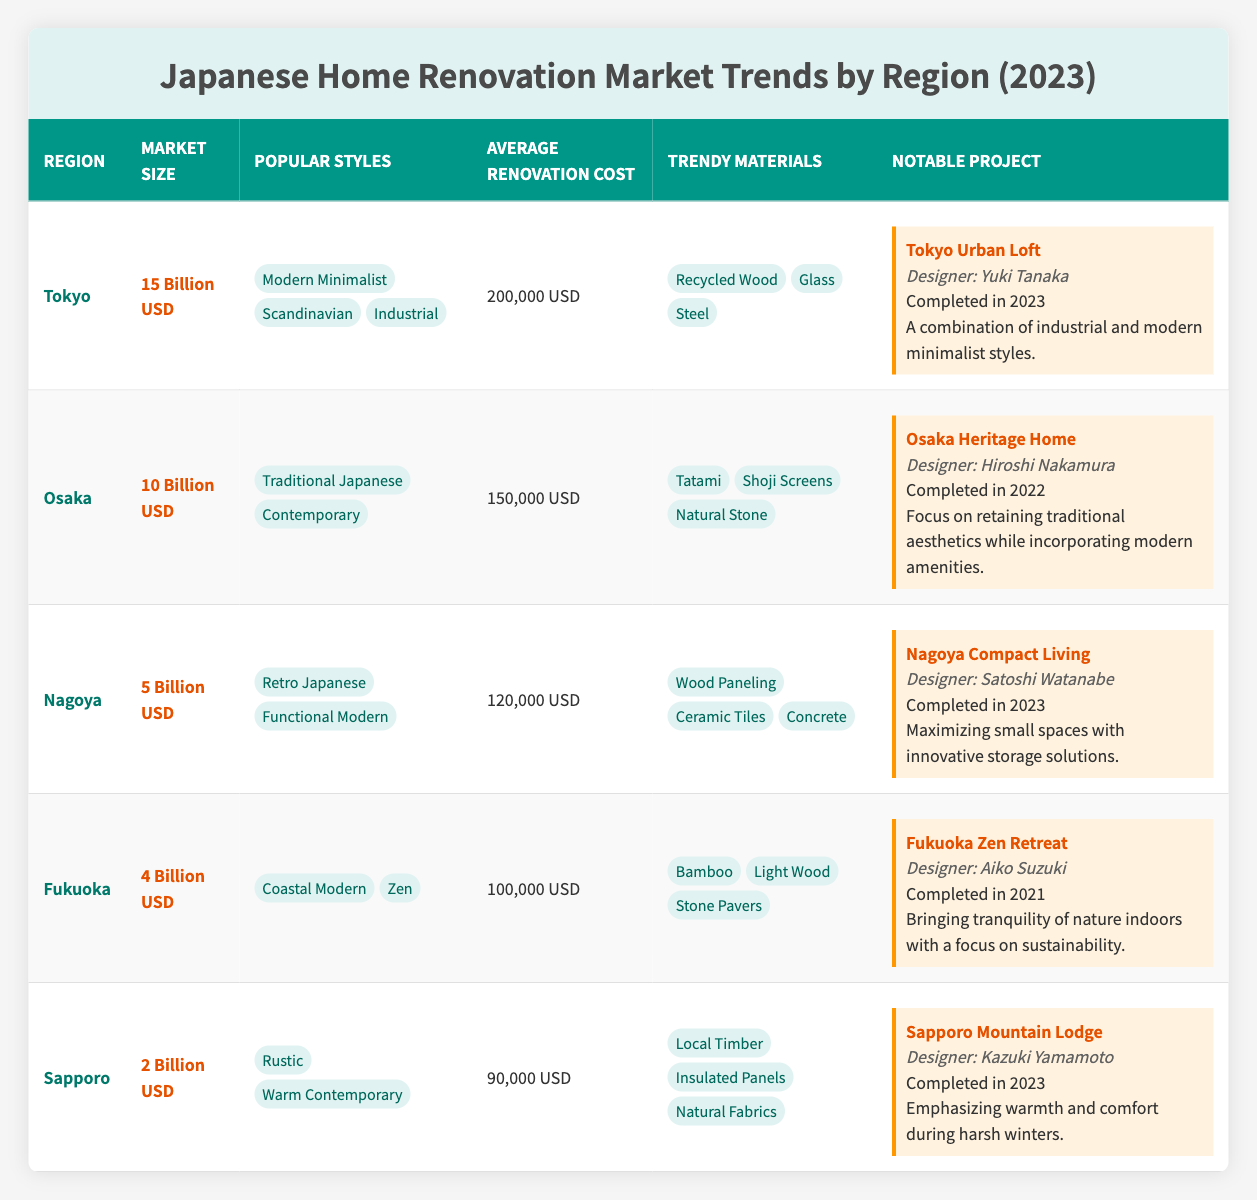What is the market size of Tokyo? The table lists Tokyo's market size as "15 Billion USD."
Answer: 15 Billion USD Which region has the highest average renovation cost? Comparing the average renovation costs, Tokyo has 200,000 USD, Osaka has 150,000 USD, Nagoya is 120,000 USD, Fukuoka is 100,000 USD, and Sapporo is 90,000 USD. Therefore, Tokyo has the highest average renovation cost.
Answer: Tokyo What trendy materials are popular in Osaka? The table indicates that the trendy materials in Osaka are "Tatami," "Shoji Screens," and "Natural Stone."
Answer: Tatami, Shoji Screens, Natural Stone Which region features the "Fukuoka Zen Retreat" project? The notable project named "Fukuoka Zen Retreat" is listed under the Fukuoka region in the table.
Answer: Fukuoka Is the average renovation cost in Nagoya higher than in Fukuoka? The average renovation cost for Nagoya is 120,000 USD, while Fukuoka's is 100,000 USD. Since 120,000 is greater than 100,000, Nagoya’s cost is higher.
Answer: Yes What are the popular styles in Sapporo? The table shows that the popular styles in Sapporo are "Rustic" and "Warm Contemporary."
Answer: Rustic, Warm Contemporary Which region has the combination of industrial and modern minimalist styles in its notable project? The "Tokyo Urban Loft" project, noted for its combination of industrial and modern minimalist styles, is located in Tokyo.
Answer: Tokyo What is the total market size of Japan’s top three regions? Adding the market sizes of Tokyo (15 Billion USD), Osaka (10 Billion USD), and Nagoya (5 Billion USD) gives a total of 15 + 10 + 5 = 30 Billion USD.
Answer: 30 Billion USD How much lower is Fukuoka’s average renovation cost compared to Tokyo's? The average renovation cost in Fukuoka is 100,000 USD, while in Tokyo it is 200,000 USD. Subtracting gives 200,000 - 100,000 = 100,000 USD.
Answer: 100,000 USD Is "Steel" listed as a trendy material in Fukuoka? "Steel" is mentioned as a trendy material in Tokyo but not in Fukuoka, which features "Bamboo," "Light Wood," and "Stone Pavers."
Answer: No Which designer is associated with the "Nagoya Compact Living" project? The table states that Satoshi Watanabe is the designer of the "Nagoya Compact Living" project.
Answer: Satoshi Watanabe In which year was the "Osaka Heritage Home" completed? The table specifies that the completion year for the "Osaka Heritage Home" project is 2022.
Answer: 2022 What percentage of the total market size does Sapporo represent? The total market size is 15 + 10 + 5 + 4 + 2 = 36 Billion USD. Sapporo's market size is 2 Billion USD, so (2/36) * 100 = 5.56%.
Answer: 5.56% 